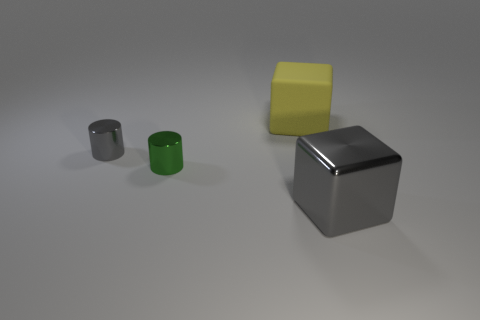Add 2 small cyan shiny objects. How many objects exist? 6 Subtract 0 blue cylinders. How many objects are left? 4 Subtract all big yellow matte blocks. Subtract all rubber objects. How many objects are left? 2 Add 3 big yellow blocks. How many big yellow blocks are left? 4 Add 1 gray blocks. How many gray blocks exist? 2 